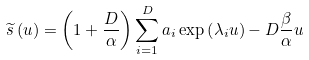Convert formula to latex. <formula><loc_0><loc_0><loc_500><loc_500>\widetilde { s } \left ( u \right ) = \left ( 1 + \frac { D } { \alpha } \right ) \sum _ { i = 1 } ^ { D } a _ { i } \exp \left ( \lambda _ { i } u \right ) - D \frac { \beta } { \alpha } u</formula> 